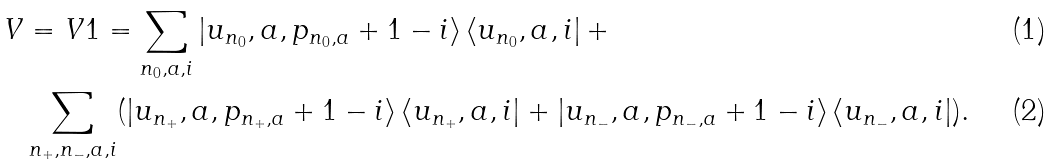Convert formula to latex. <formula><loc_0><loc_0><loc_500><loc_500>V & = V 1 = \sum _ { n _ { 0 } , a , i } \left | u _ { n _ { 0 } } , a , p _ { n _ { 0 } , a } + 1 - i \right \rangle \left \langle u _ { n _ { 0 } } , a , i \right | + \\ & \sum _ { n _ { + } , n _ { - } , a , i } ( \left | u _ { n _ { + } } , a , p _ { n _ { + } , a } + 1 - i \right \rangle \left \langle u _ { n _ { + } } , a , i \right | + \left | u _ { n _ { - } } , a , p _ { n _ { - } , a } + 1 - i \right \rangle \left \langle u _ { n _ { - } } , a , i \right | ) .</formula> 